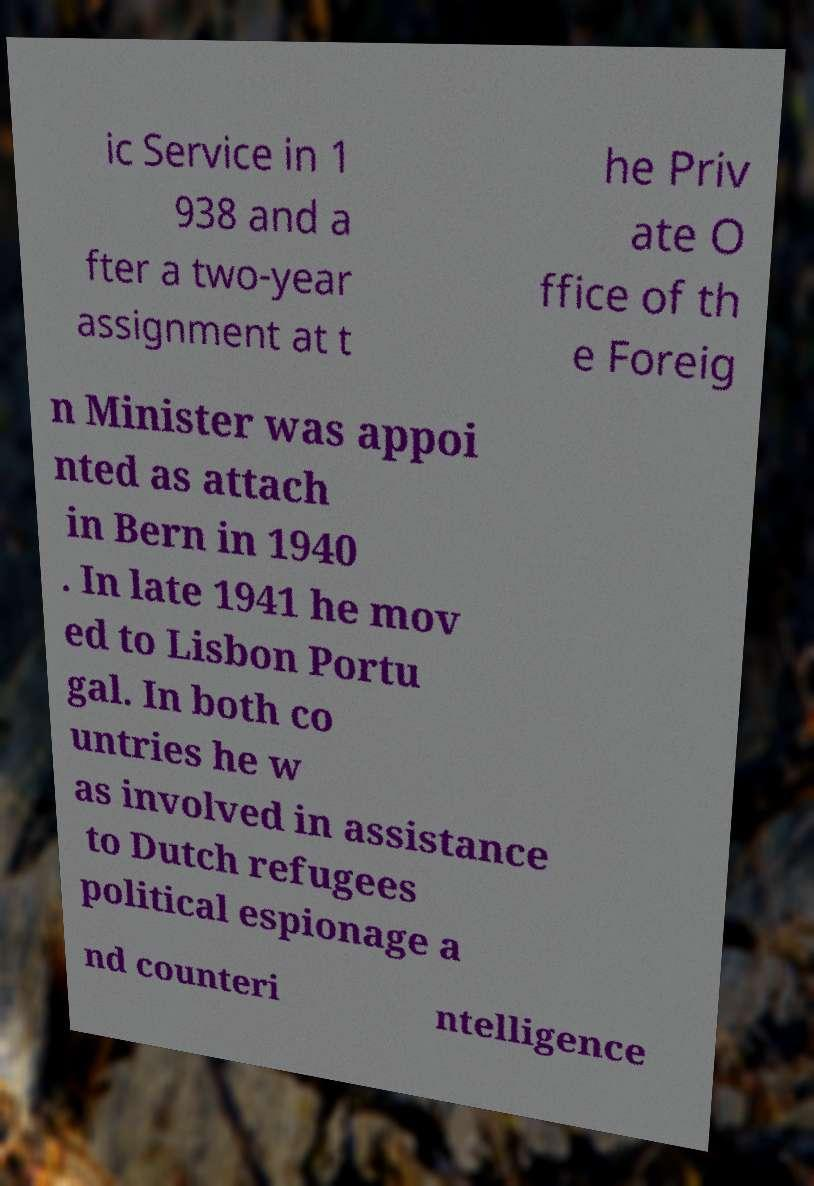Can you read and provide the text displayed in the image?This photo seems to have some interesting text. Can you extract and type it out for me? ic Service in 1 938 and a fter a two-year assignment at t he Priv ate O ffice of th e Foreig n Minister was appoi nted as attach in Bern in 1940 . In late 1941 he mov ed to Lisbon Portu gal. In both co untries he w as involved in assistance to Dutch refugees political espionage a nd counteri ntelligence 